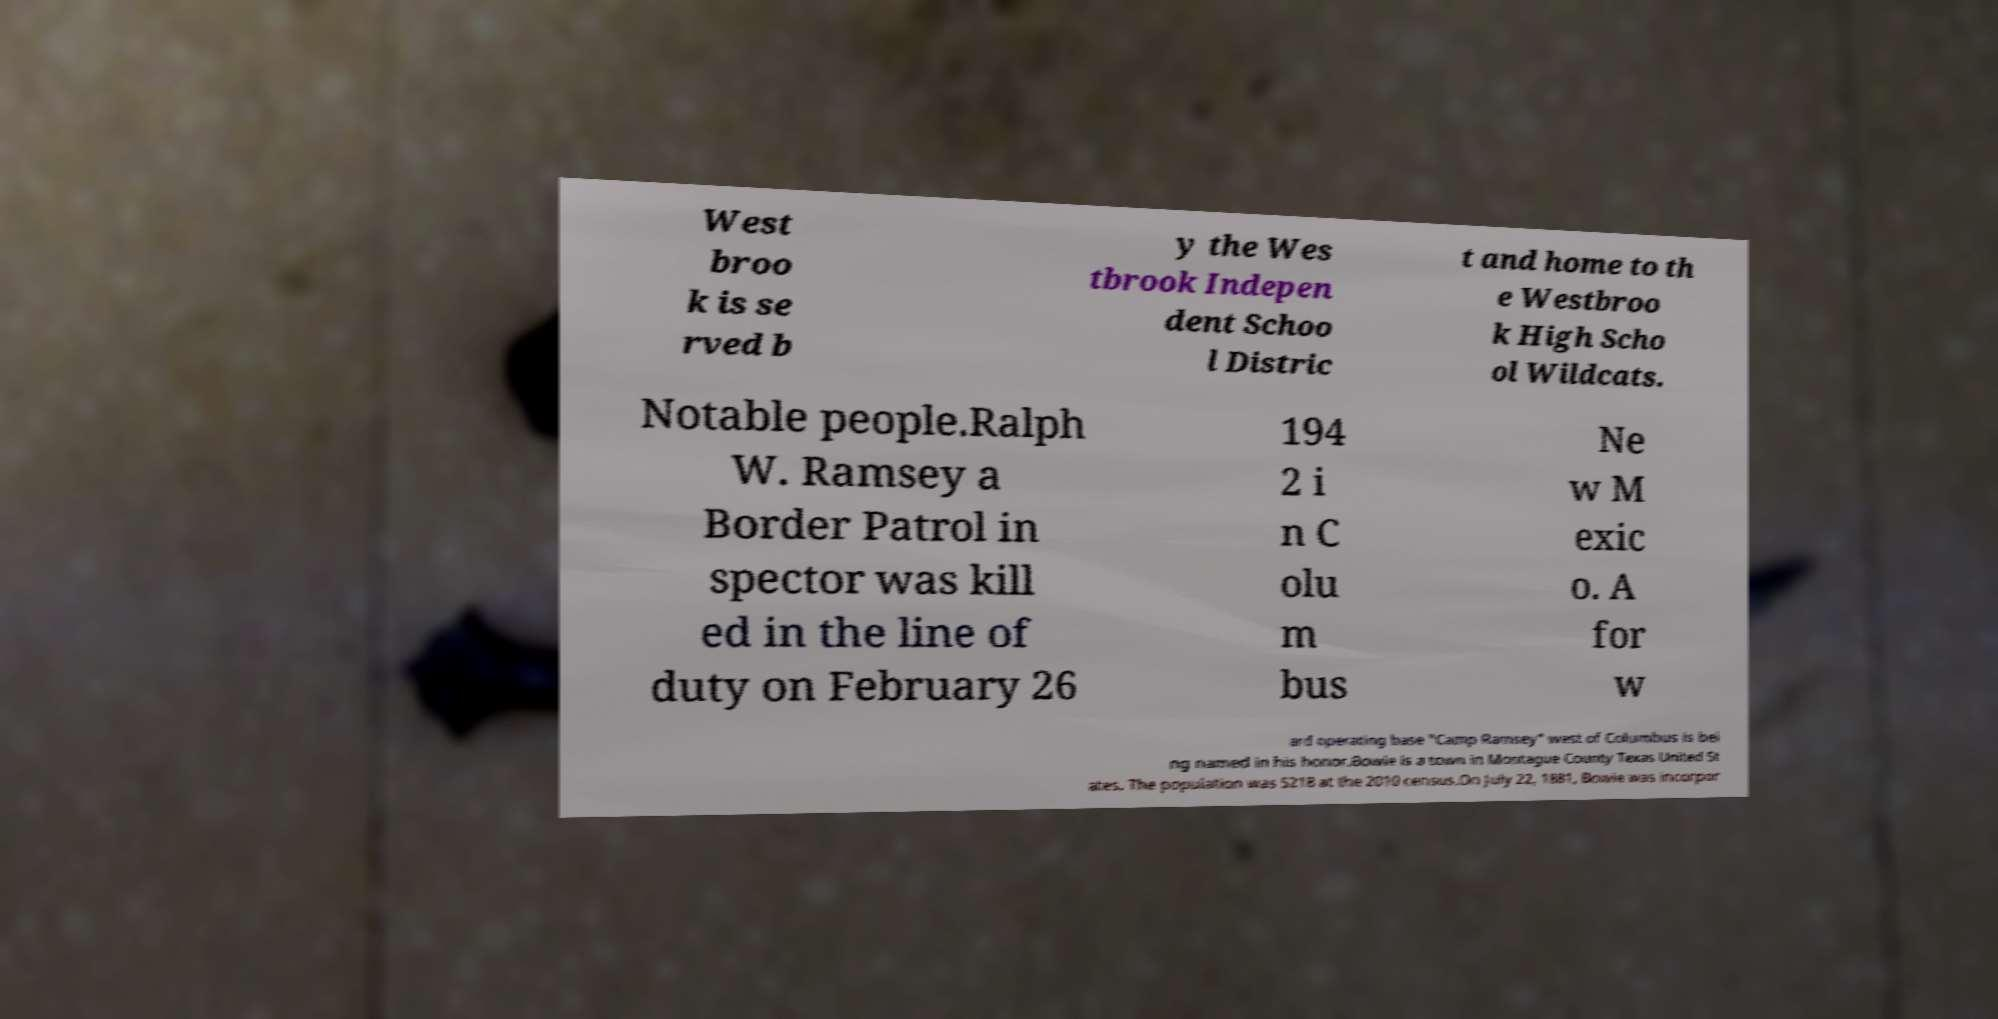What messages or text are displayed in this image? I need them in a readable, typed format. West broo k is se rved b y the Wes tbrook Indepen dent Schoo l Distric t and home to th e Westbroo k High Scho ol Wildcats. Notable people.Ralph W. Ramsey a Border Patrol in spector was kill ed in the line of duty on February 26 194 2 i n C olu m bus Ne w M exic o. A for w ard operating base "Camp Ramsey" west of Columbus is bei ng named in his honor.Bowie is a town in Montague County Texas United St ates. The population was 5218 at the 2010 census.On July 22, 1881, Bowie was incorpor 